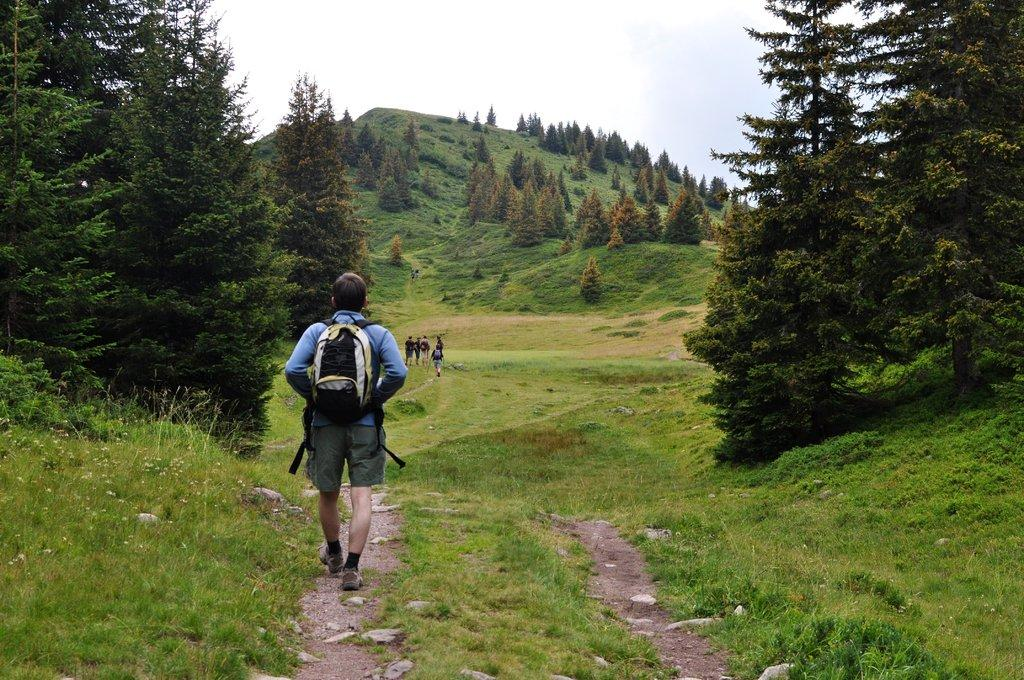Who is present in the image? There is a person in the image. What is the person carrying? The person is carrying a bag. What can be seen in the background of the image? There are trees and other people in the background of the image. What type of noise is the horn making in the image? There is no horn present in the image, so it is not possible to determine what noise it might be making. 